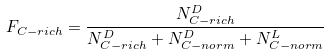Convert formula to latex. <formula><loc_0><loc_0><loc_500><loc_500>F _ { C - r i c h } = \frac { N ^ { D } _ { C - r i c h } } { N ^ { D } _ { C - r i c h } + N ^ { D } _ { C - n o r m } + N ^ { L } _ { C - n o r m } }</formula> 